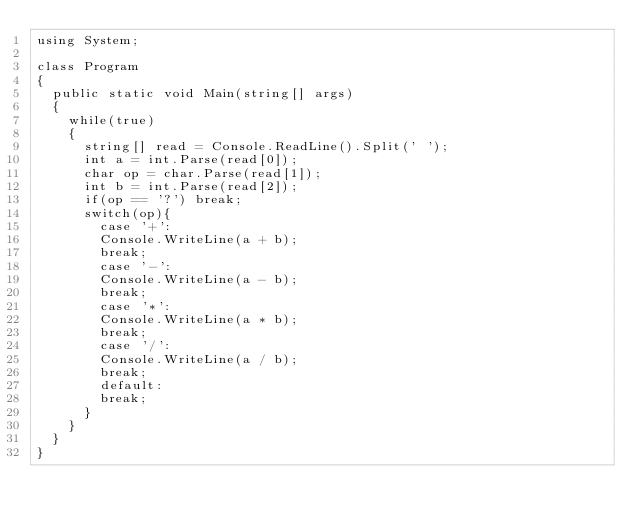<code> <loc_0><loc_0><loc_500><loc_500><_C#_>using System;

class Program
{
  public static void Main(string[] args)
  {
    while(true)
    {
      string[] read = Console.ReadLine().Split(' ');
      int a = int.Parse(read[0]);
      char op = char.Parse(read[1]);
      int b = int.Parse(read[2]);
      if(op == '?') break;
      switch(op){
        case '+':
        Console.WriteLine(a + b);
        break;
        case '-':
        Console.WriteLine(a - b);
        break;
        case '*':
        Console.WriteLine(a * b);
        break;
        case '/':
        Console.WriteLine(a / b);
        break;
        default:
        break;
      }
    }
  }
}</code> 